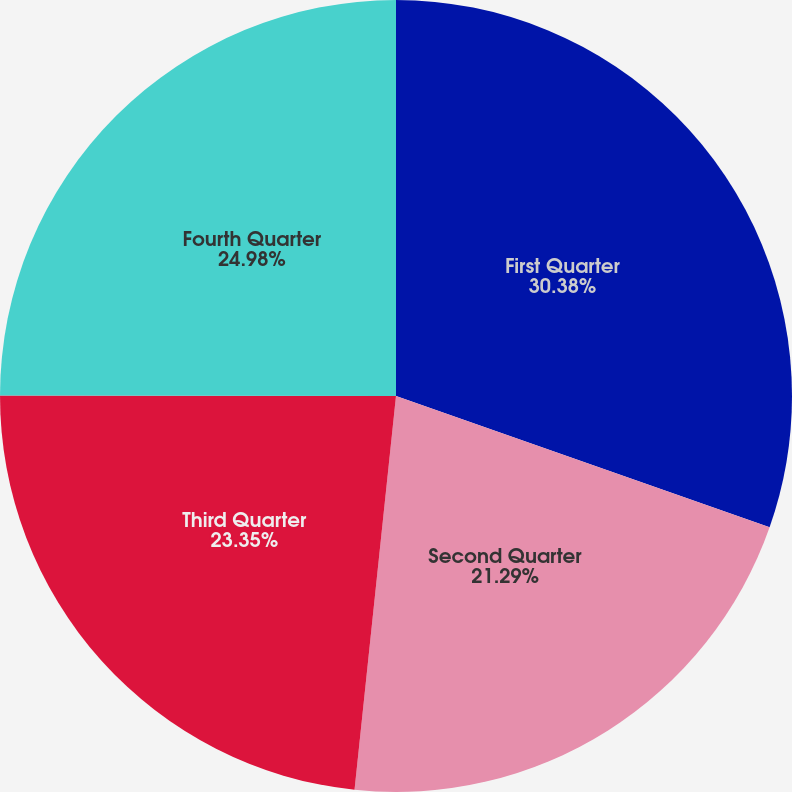<chart> <loc_0><loc_0><loc_500><loc_500><pie_chart><fcel>First Quarter<fcel>Second Quarter<fcel>Third Quarter<fcel>Fourth Quarter<nl><fcel>30.38%<fcel>21.29%<fcel>23.35%<fcel>24.98%<nl></chart> 